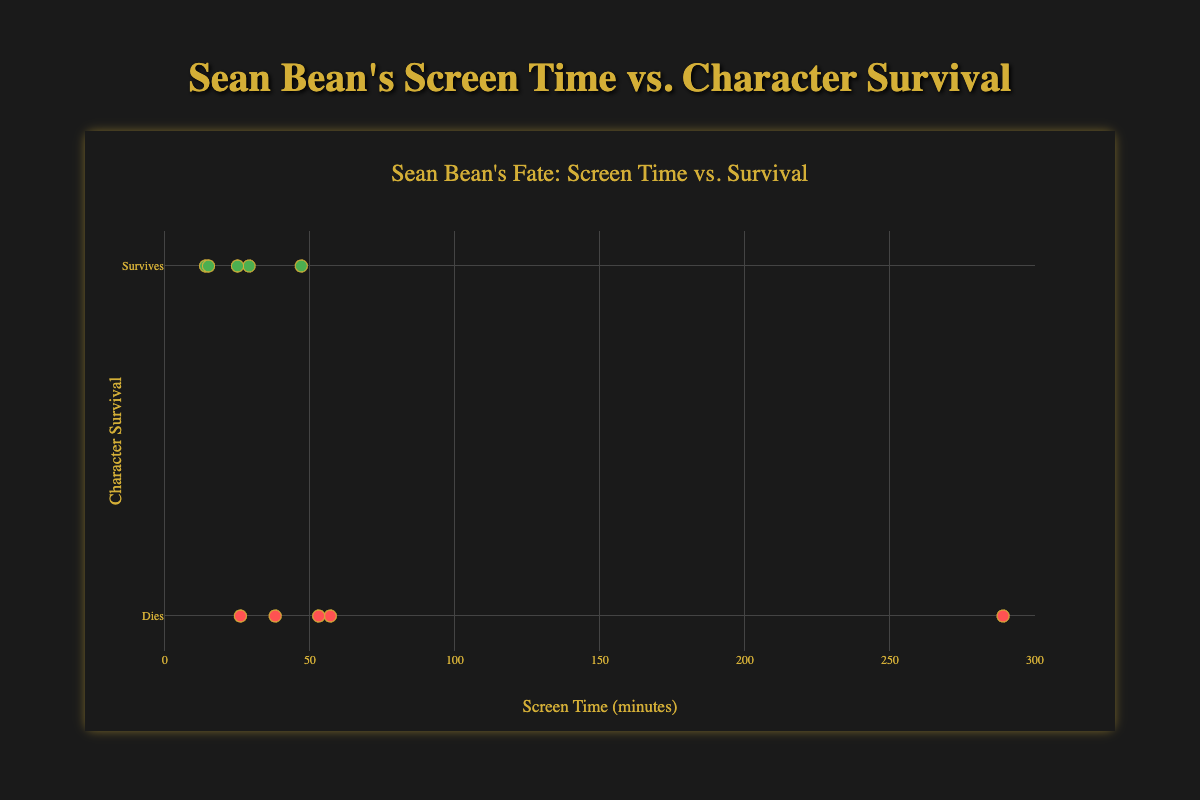What is the title of the plot? The title of the plot is located at the top and it is clearly displayed. It summarizes the figure's content in a concise way.
Answer: Sean Bean's Fate: Screen Time vs. Survival How many data points are displayed in the scatter plot? To determine the number of data points, count each marker or look at the number of titles listed in the hover information. There are 10 titles provided in the data.
Answer: 10 What is the maximum screen time in the figure? To find the maximum screen time, look at the x-axis and identify the greatest value among the markers.
Answer: 289 minutes Which movie has the highest screen time and does the character survive? The data point with the highest x value corresponds to the highest screen time. Checking this point's survival rate tells us if the character survives.
Answer: Game of Thrones (Season 1), No Identify one movie where Sean Bean's character survives with a screen time between 20 and 30 minutes. Locate data points between 20 and 30 on the x-axis and check their y-values (survival rates). Find one where the y value is 1 (survives).
Answer: Silent Hill Compare the screen times of "GoldenEye" and "The Island." Which one is higher? Locate the data points for "GoldenEye" and "The Island" and compare their x values to see which is larger.
Answer: The Island Calculate the average screen time of the movies where Sean Bean's character survives. Identify the data points where the y value is 1 (survives). Sum their x values and divide by the number of such points. (47 + 14 + 29 + 15 + 25) / 5.
Answer: 26 minutes What can you infer about Sean Bean's character survival in relation to his screen time? Examine the distribution of points where y is 1 (survives) and those where y is 0 (dies), relative to their x values (screen times). More points where y is 0 may suggest a pattern.
Answer: No clear correlation between screen time and survival Between "National Treasure" and "The Martian," which movie has a higher survival rate for Sean Bean's character? Compare the y values (survival rates) of the data points for "National Treasure" and "The Martian." Both have a y value of 1.
Answer: Both have high survival rates What percentage of the movies does Sean Bean's character survive? Count the data points where the y value is 1 (survives) and divide by the total number of data points, then multiply by 100. (5/10) * 100.
Answer: 50% 